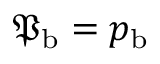Convert formula to latex. <formula><loc_0><loc_0><loc_500><loc_500>{ \mathfrak { P } } _ { b } = { p } _ { b }</formula> 